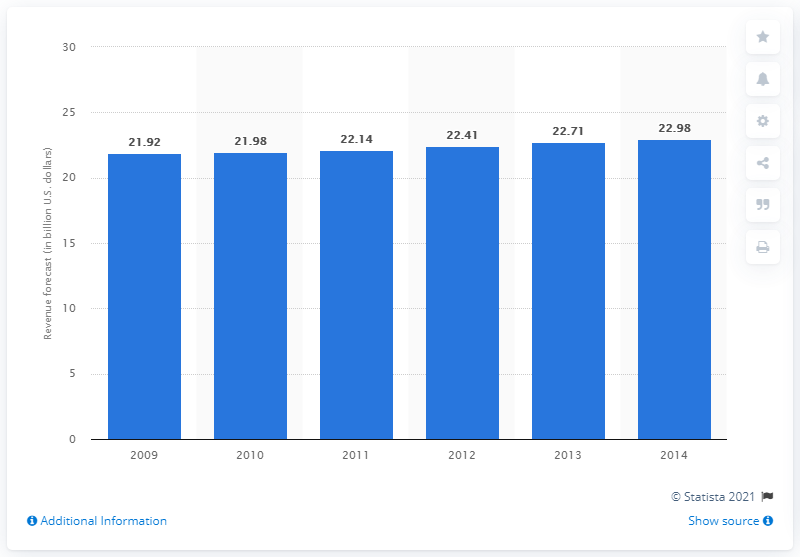Highlight a few significant elements in this photo. The estimated revenue for the U.S. toys and games market in 2010 was 22.14 billion dollars. 